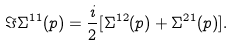<formula> <loc_0><loc_0><loc_500><loc_500>\Im \Sigma ^ { 1 1 } ( p ) = \frac { i } { 2 } [ \Sigma ^ { 1 2 } ( p ) + \Sigma ^ { 2 1 } ( p ) ] .</formula> 